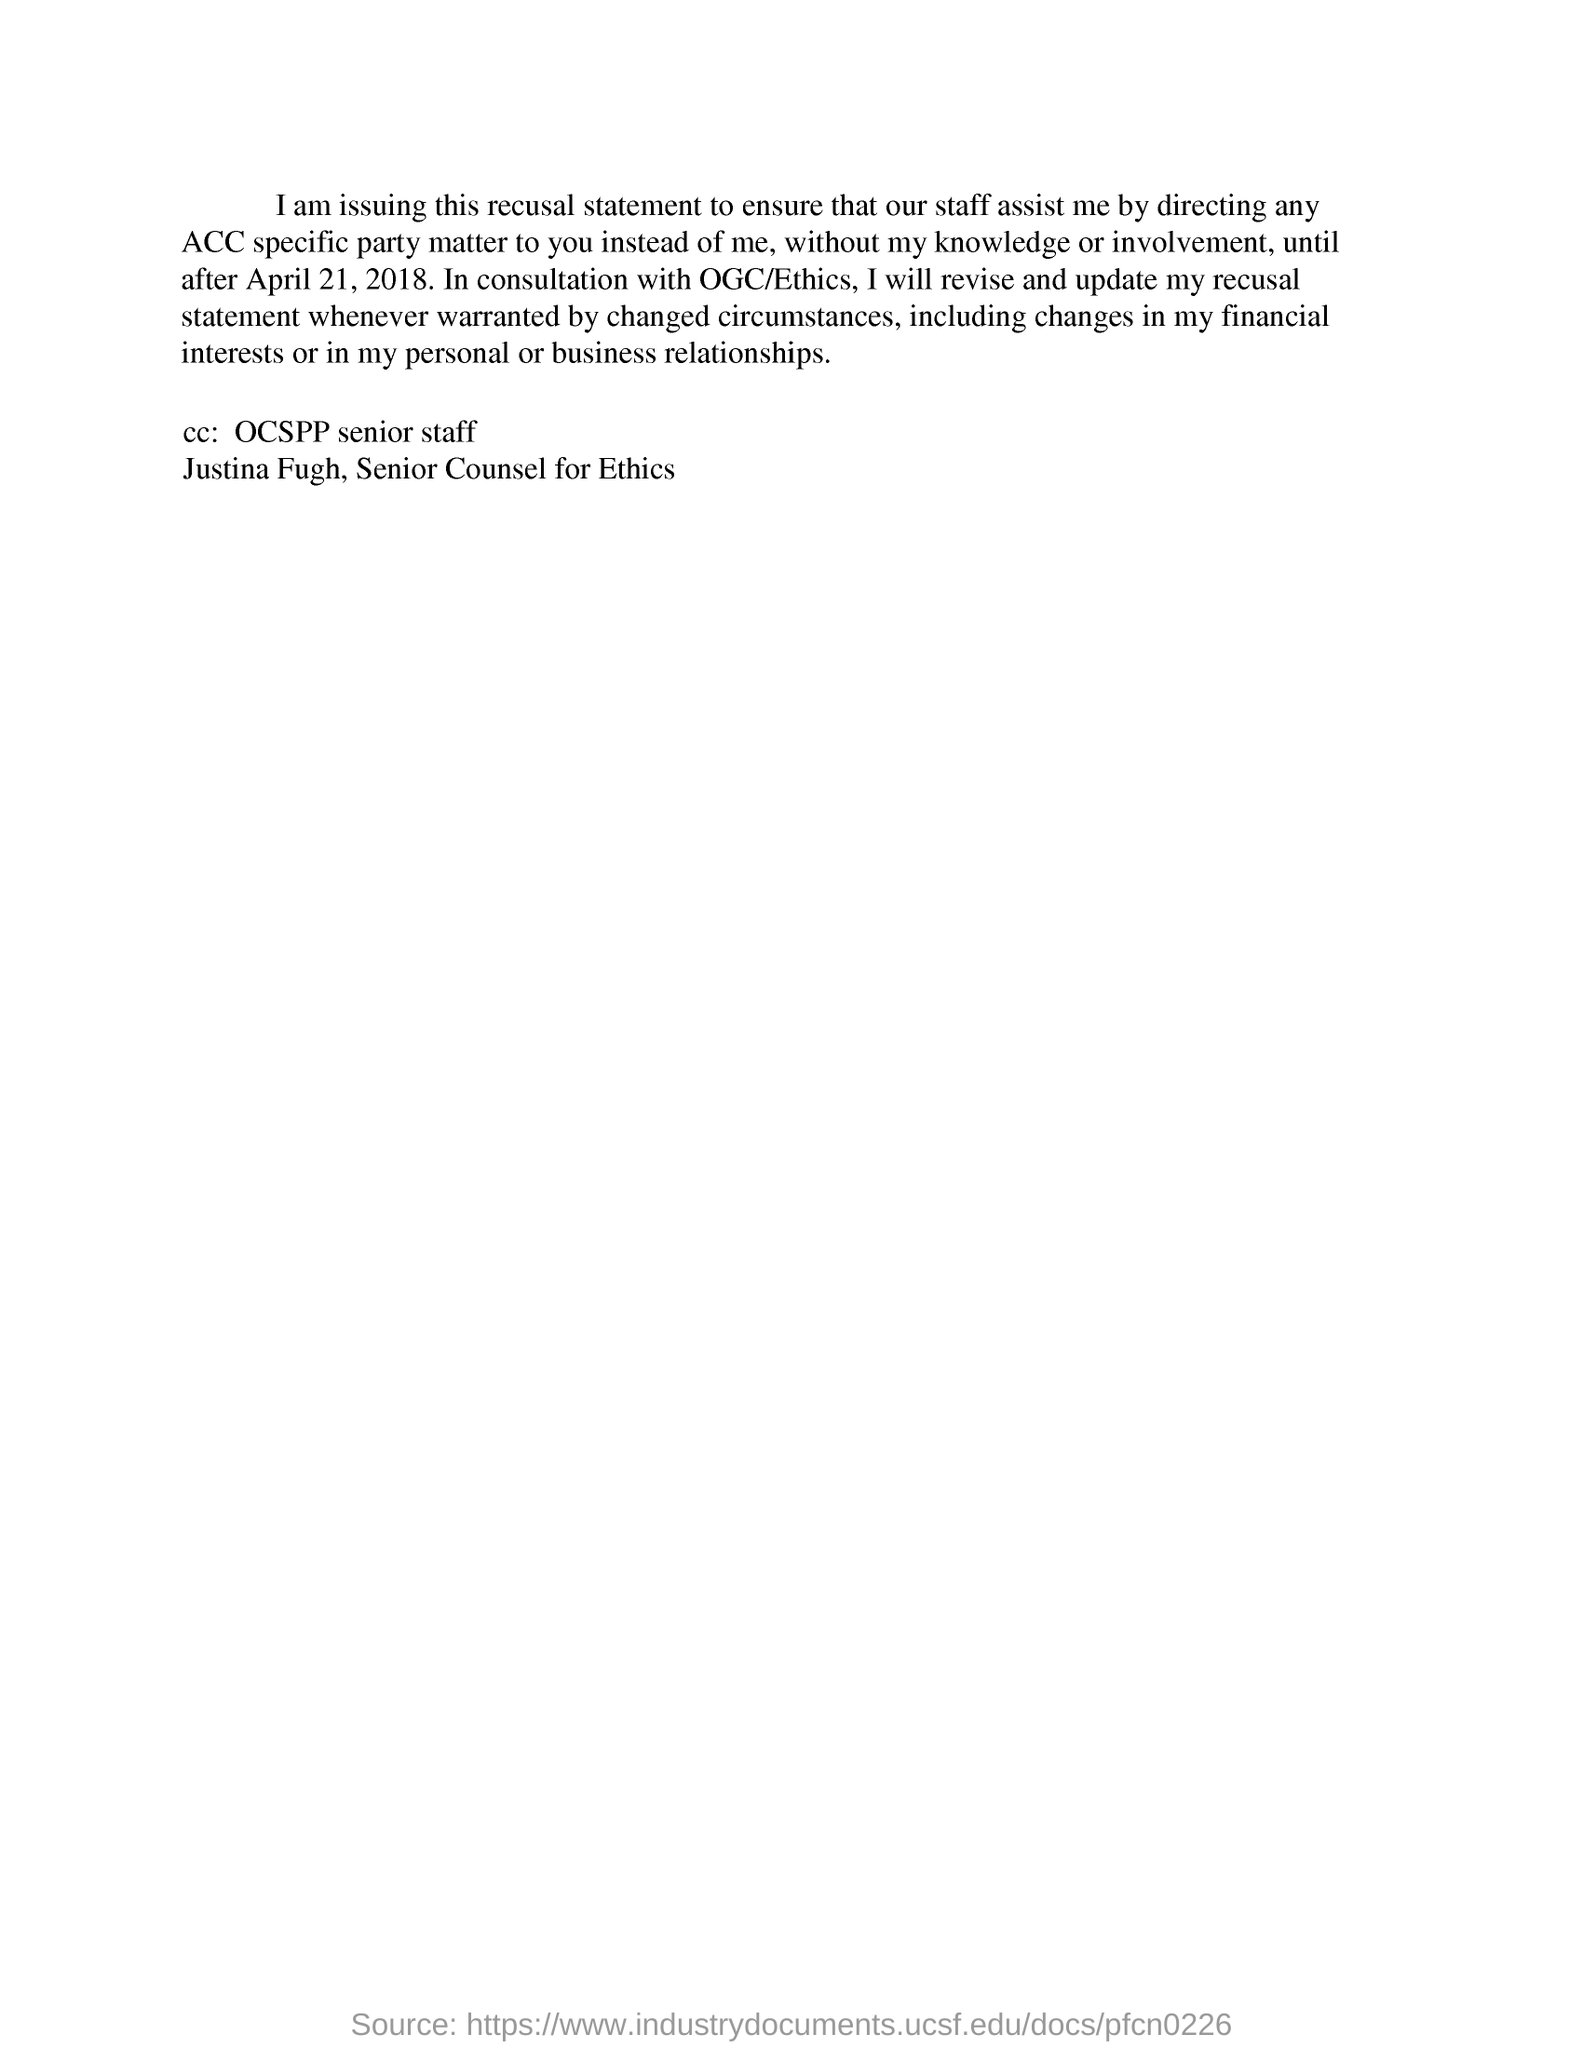Draw attention to some important aspects in this diagram. Justina Fugh, a senior staff member of the CC: and the Senior Counsel for Ethics, is mentioned in the CC:. 